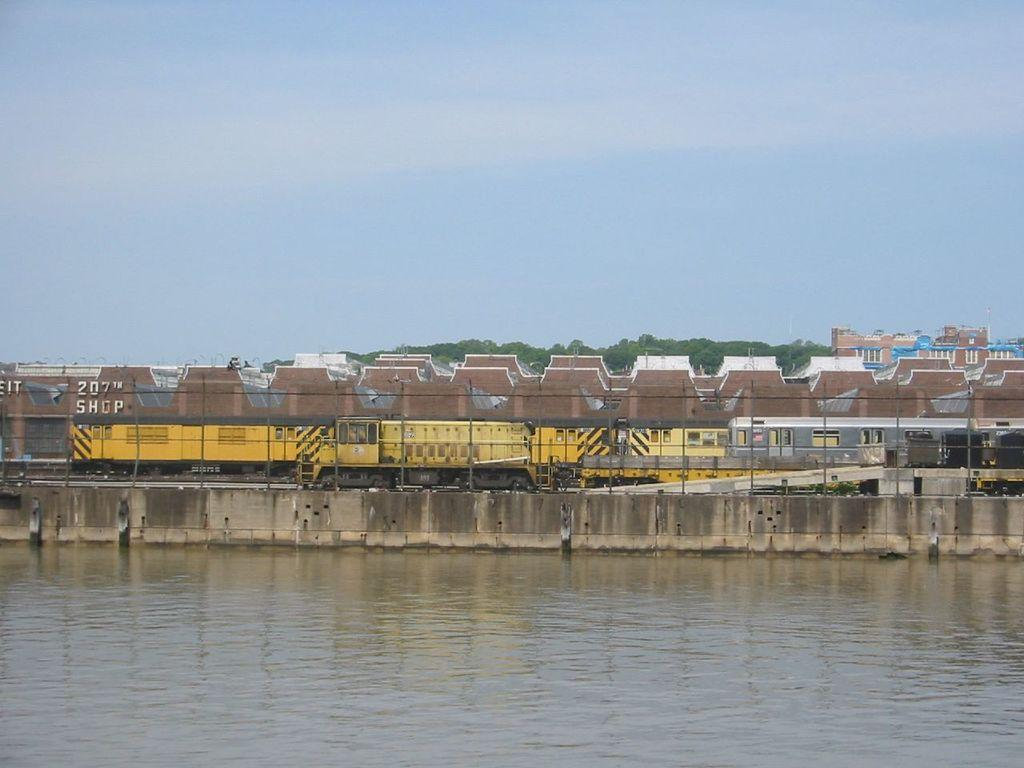What is visible in the image? There is water, walls, a train, poles, trees, a building, and the sky visible in the image. Can you describe the train in the image? The train is a mode of transportation and is present in the image. What type of vegetation can be seen in the image? Trees are the type of vegetation visible in the image. What is the background of the image? The sky is visible in the background of the image. How many minutes does it take for the girls to finish the milk in the image? There are no girls or milk present in the image, so it is not possible to answer that question. 